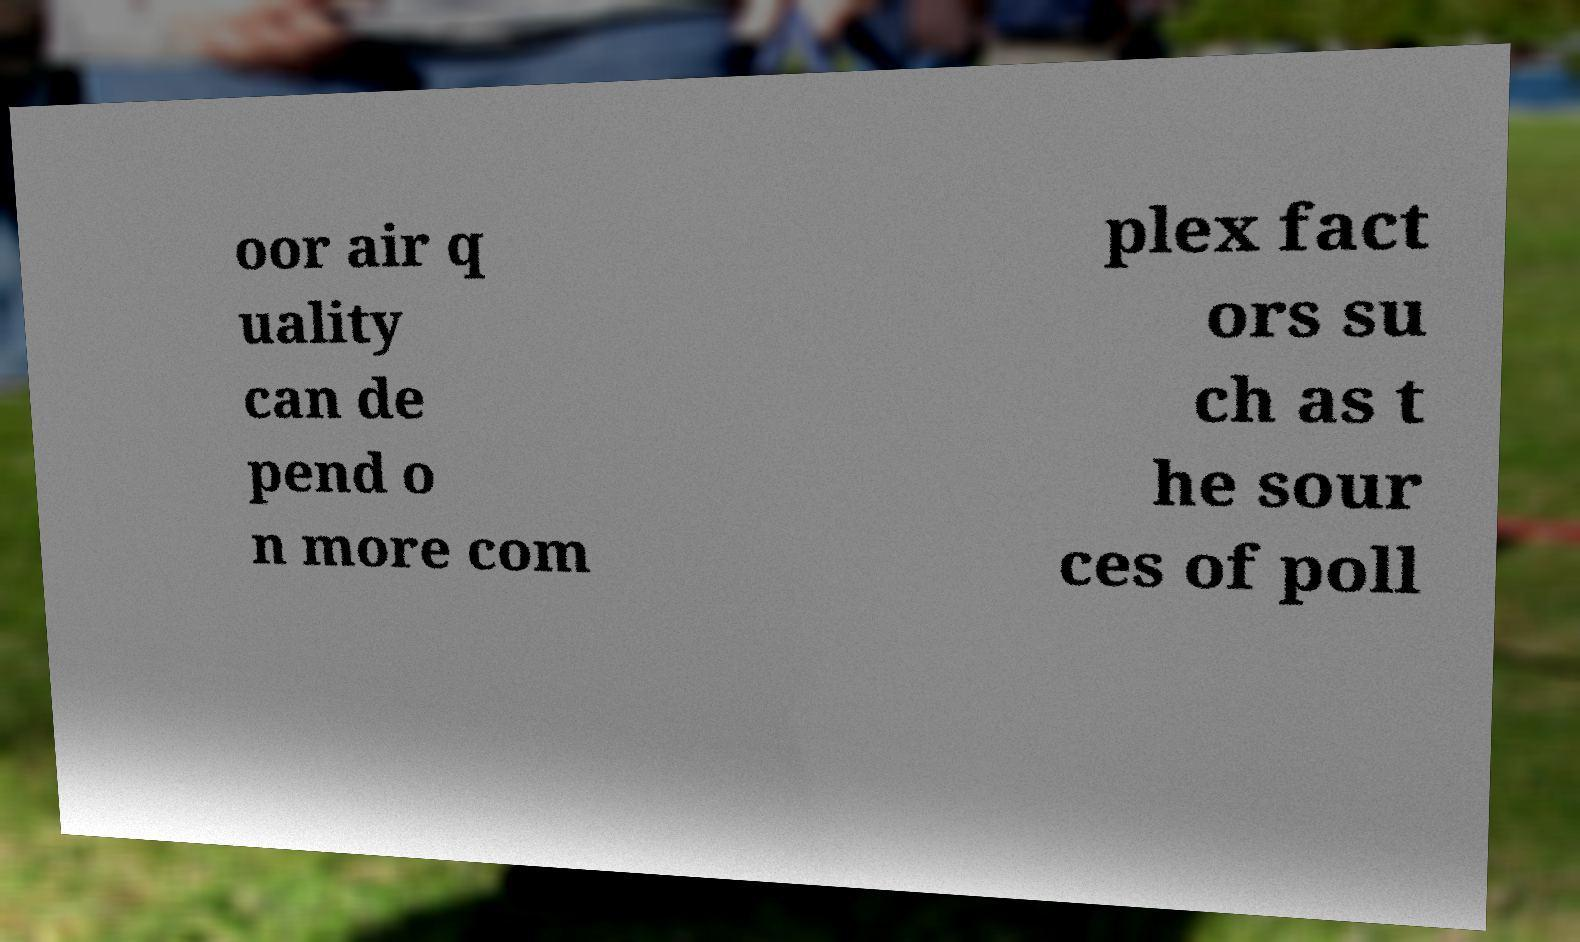What messages or text are displayed in this image? I need them in a readable, typed format. oor air q uality can de pend o n more com plex fact ors su ch as t he sour ces of poll 